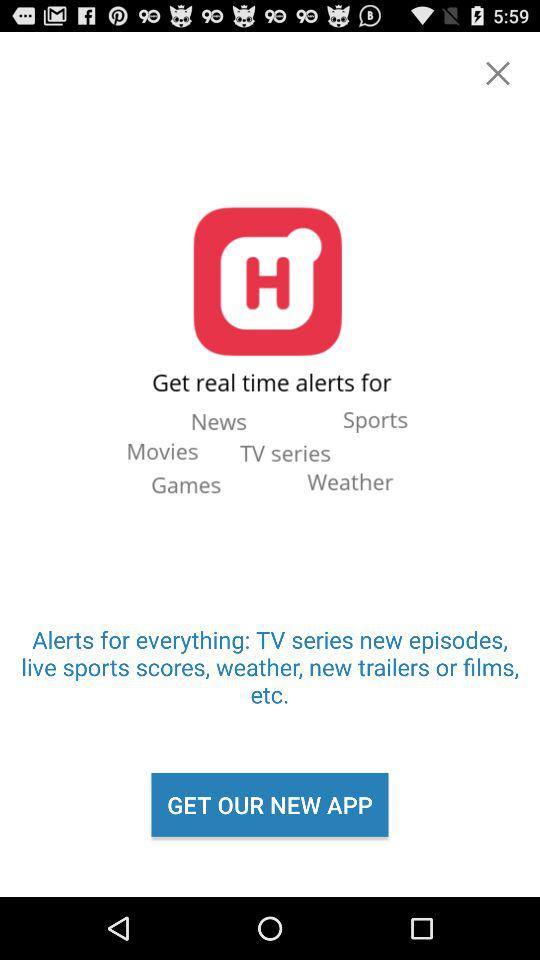How much is the new app?
When the provided information is insufficient, respond with <no answer>. <no answer> 